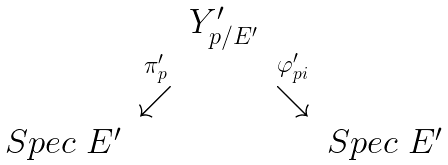<formula> <loc_0><loc_0><loc_500><loc_500>\begin{array} { c c c c c } \ & \ & Y ^ { \prime } _ { p / E ^ { \prime } } & \ & \ \\ \ & \stackrel { \pi ^ { \prime } _ { p } } { \swarrow } & \ & \stackrel { \varphi ^ { \prime } _ { p i } } { \searrow } & \ \\ S p e c \ E ^ { \prime } & \ & \ & \ & S p e c \ E ^ { \prime } \end{array}</formula> 